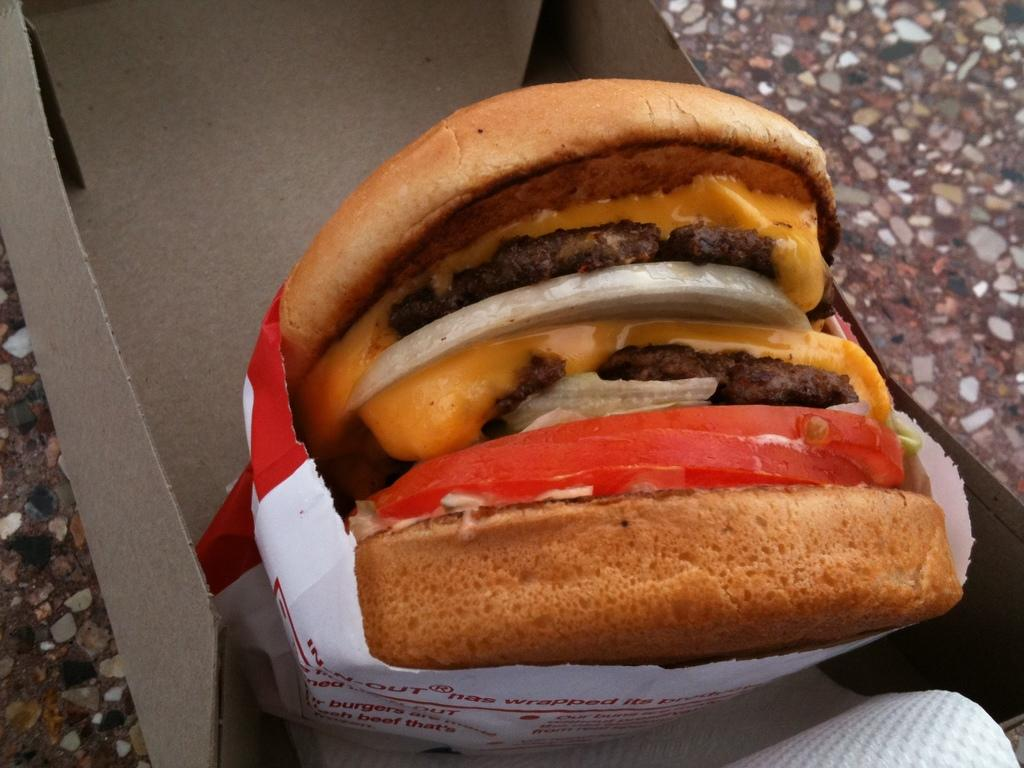What type of food is in the image? There is a burger in the image. What colors can be seen on the burger? The burger has brown, black, cream, orange, and red colors. How is the burger contained in the image? The burger is in a paper cover, which is in a box. What is the color of the background in the image? The background of the image is brown. What rule is being enforced in the image? There is no rule being enforced in the image; it features a burger in a paper cover and a box. What type of vacation destination can be seen in the image? There is no vacation destination present in the image; it features a burger in a paper cover and a box. 